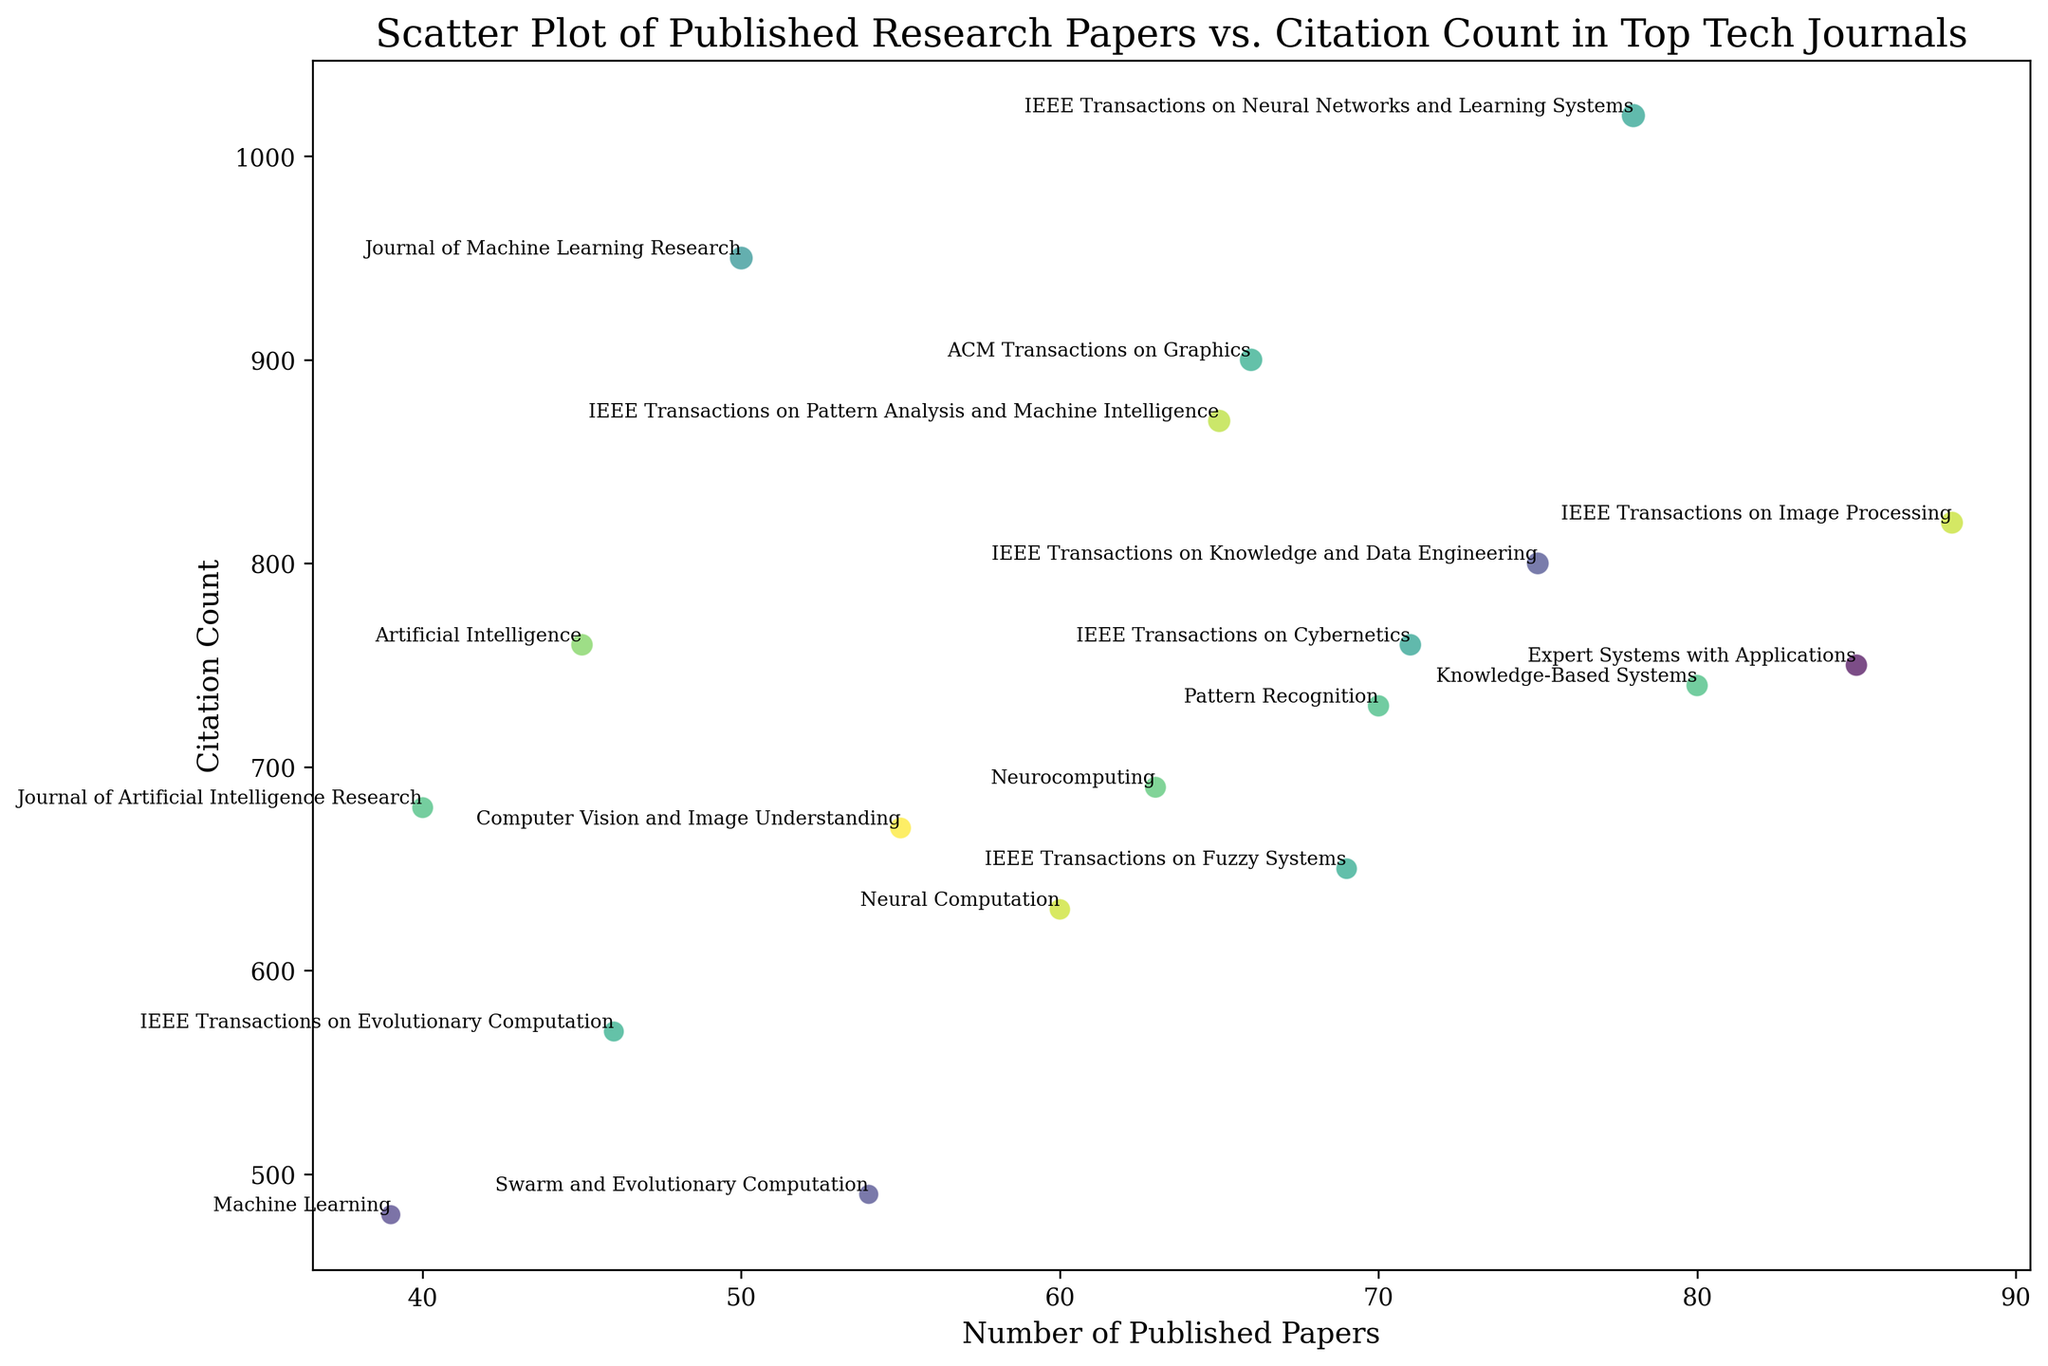Which journal has the highest number of published papers? By visually inspecting the x-axis (Number of Published Papers) and identifying the point furthest to the right, we see that IEEE Transactions on Image Processing has the highest number of published papers.
Answer: IEEE Transactions on Image Processing How many journals have a citation count of more than 800? By looking at the y-axis and counting the points that are above 800, we can identify that there are three journals (IEEE Transactions on Neural Networks and Learning Systems, Journal of Machine Learning Research, and ACM Transactions on Graphics).
Answer: Three Which journal has both a high number of published papers and a high citation count? We need to find points that are both far to the right on the x-axis and high on the y-axis. IEEE Transactions on Neural Networks and Learning Systems is high in both number of published papers (78) and citation count (1020).
Answer: IEEE Transactions on Neural Networks and Learning Systems Is there a journal with a higher citation count but fewer published papers compared to "Artificial Intelligence"? First, check the position of Artificial Intelligence (45, 760). Then, identify any journal above 760 citation count but less than 45 published papers. There is no such journal in the plot.
Answer: No What is the average citation count of journals with more than 70 published papers? First, identify journals with more than 70 published papers: IEEE Transactions on Neural Networks and Learning Systems, Pattern Recognition, IEEE Transactions on Cybernetics, IEEE Transactions on Knowledge and Data Engineering, and Expert Systems with Applications. Sum their citation counts (1020 + 730 + 760 + 800 + 750 = 4060) and divide by 5 (4060/5).
Answer: 812 Which journal is closest in published papers to "Neurocomputing" but has a higher citation count? Neurocomputing has 63 published papers with 690 citations. The closest journal in published papers is IEEE Transactions on Image Processing (88 published papers) with a citation count of 820, which is higher.
Answer: IEEE Transactions on Image Processing Among the journals with citation counts between 600 and 800, which has the smallest number of published papers? Find points between 600 and 800 on the y-axis, then find the one with the smallest x-axis value. "IEEE Transactions on Fuzzy Systems" (69, 650) has a smaller published paper count than others in this range.
Answer: IEEE Transactions on Fuzzy Systems Which journal has the second-highest citation count among those with more than 60 published papers? First filter journals with more than 60 published papers, then rank them by citation count. IEEE Transactions on Pattern Analysis and Machine Intelligence has 65 papers and the second-highest citation count of 870 after IEEE Transactions on Neural Networks and Learning Systems (1020).
Answer: IEEE Transactions on Pattern Analysis and Machine Intelligence 